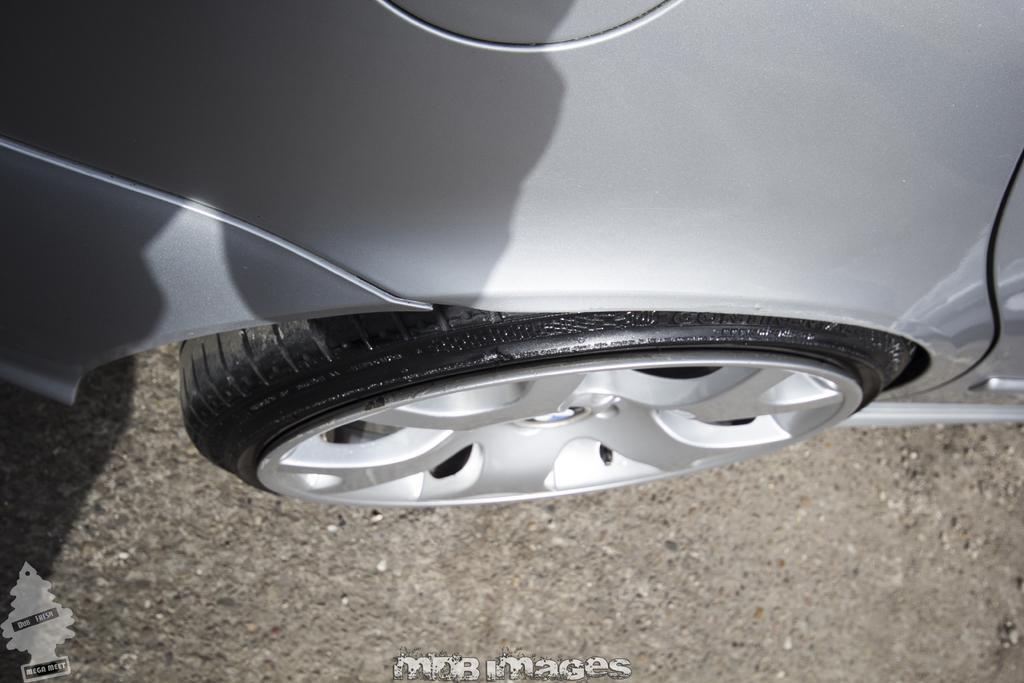Describe this image in one or two sentences. In this image in the center there is one car, at the bottom there is road and at the bottom of the image there is some text. 